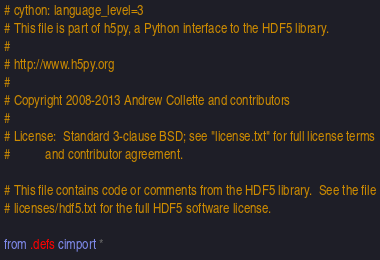<code> <loc_0><loc_0><loc_500><loc_500><_Cython_># cython: language_level=3
# This file is part of h5py, a Python interface to the HDF5 library.
#
# http://www.h5py.org
#
# Copyright 2008-2013 Andrew Collette and contributors
#
# License:  Standard 3-clause BSD; see "license.txt" for full license terms
#           and contributor agreement.

# This file contains code or comments from the HDF5 library.  See the file
# licenses/hdf5.txt for the full HDF5 software license.

from .defs cimport *
</code> 